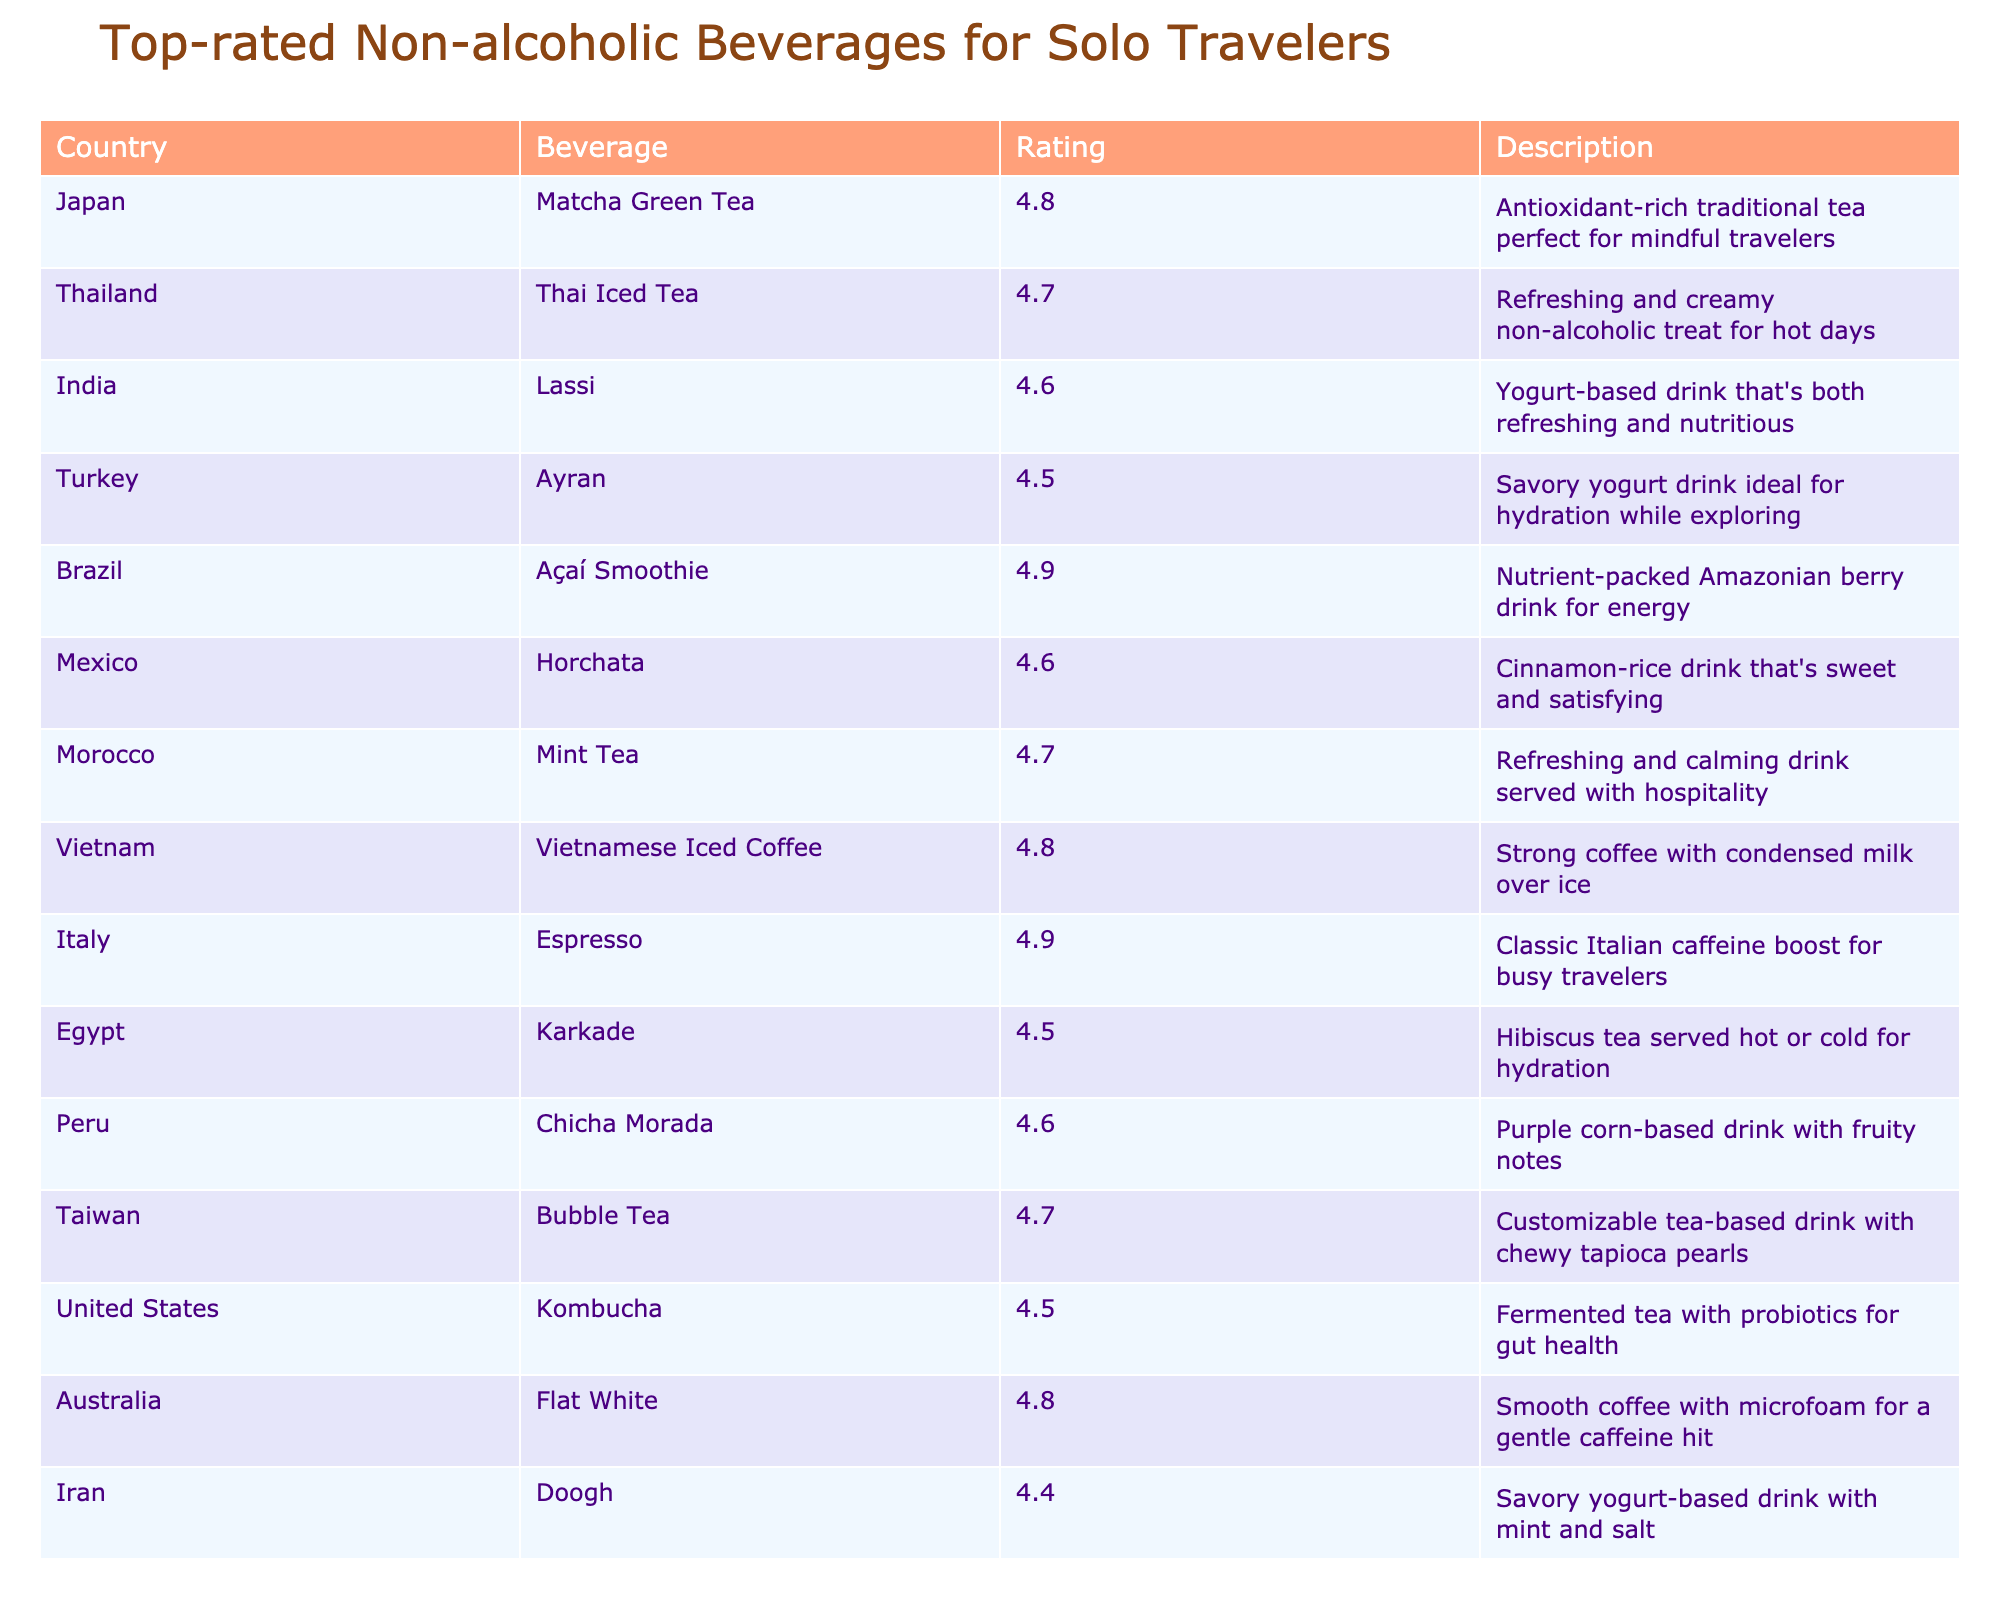What is the highest-rated beverage in the table? By inspecting the “Rating” column, the highest value is 4.9, corresponding to both the "Açaí Smoothie" and "Espresso" beverages.
Answer: Açaí Smoothie and Espresso Which beverage has a rating of 4.7? Looking through the “Rating” column, I see that the beverages "Thai Iced Tea," "Mint Tea," "Vietnamese Iced Coffee," "Taiwan Bubble Tea," and "Argentina Mate" all have a rating of 4.7.
Answer: Thai Iced Tea, Mint Tea, Vietnamese Iced Coffee, Bubble Tea, Mate Is there a beverage from India in the table? Checking the “Country” column, I find "India" listed, and it corresponds to the beverage "Lassi."
Answer: Yes What beverage has the lowest rating and what is that rating? The “Rating” column shows "Doogh" and "Kvass," each with the lowest rating of 4.4.
Answer: Doogh and Kvass, 4.4 How many beverages are rated above 4.6? Counting the ratings that exceed 4.6, we find "Matcha Green Tea," "Açaí Smoothie," "Espresso," "Thai Iced Tea," "Mint Tea," "Vietnamese Iced Coffee," "Bubble Tea," "Flat White," and "Milo Dinosaur." This gives us a total of 9 beverages.
Answer: 9 What is the average rating of all beverages listed? To find the average, sum up all the ratings (total 4.8 + 4.7 + 4.6 + 4.5 + 4.9 + 4.6 + 4.7 + 4.8 + 4.9 + 4.5 + 4.6 + 4.7 + 4.5 + 4.6 + 4.4 + 4.6 + 4.5 + 4.4 + 4.7 = 87.2) and divide by the number of beverages (18), which results in an average rating of approximately 4.84.
Answer: 4.84 Which beverage has a description related to hydration? “Ayran” and “Karkade” both have descriptions mentioning hydration. "Ayran" states it is ideal for hydration while exploring, and "Karkade" as a refreshing drink served hot or cold for hydration.
Answer: Ayran, Karkade Which country has the beverage with the highest rating? Analyzing the highest rating of 4.9, I find it belongs to both Brazil (Açaí Smoothie) and Italy (Espresso). Thus, both countries have the highest-rated beverages.
Answer: Brazil and Italy Is "Kombucha" a traditional beverage from its respective country? Kombucha is associated with the United States in the table. While it’s popular there, it is originally from Asia. Thus this is a nuanced yes or no question.
Answer: No, it's not traditional to the U.S How many beverages come from Asia? The countries in Asia listed are Japan (Matcha), Thailand (Thai Iced Tea), India (Lassi), Turkey (Ayran), Vietnam (Vietnamese Iced Coffee), Taiwan (Bubble Tea), Iran (Doogh), and Singapore (Milo Dinosaur). This totals 8 beverages.
Answer: 8 